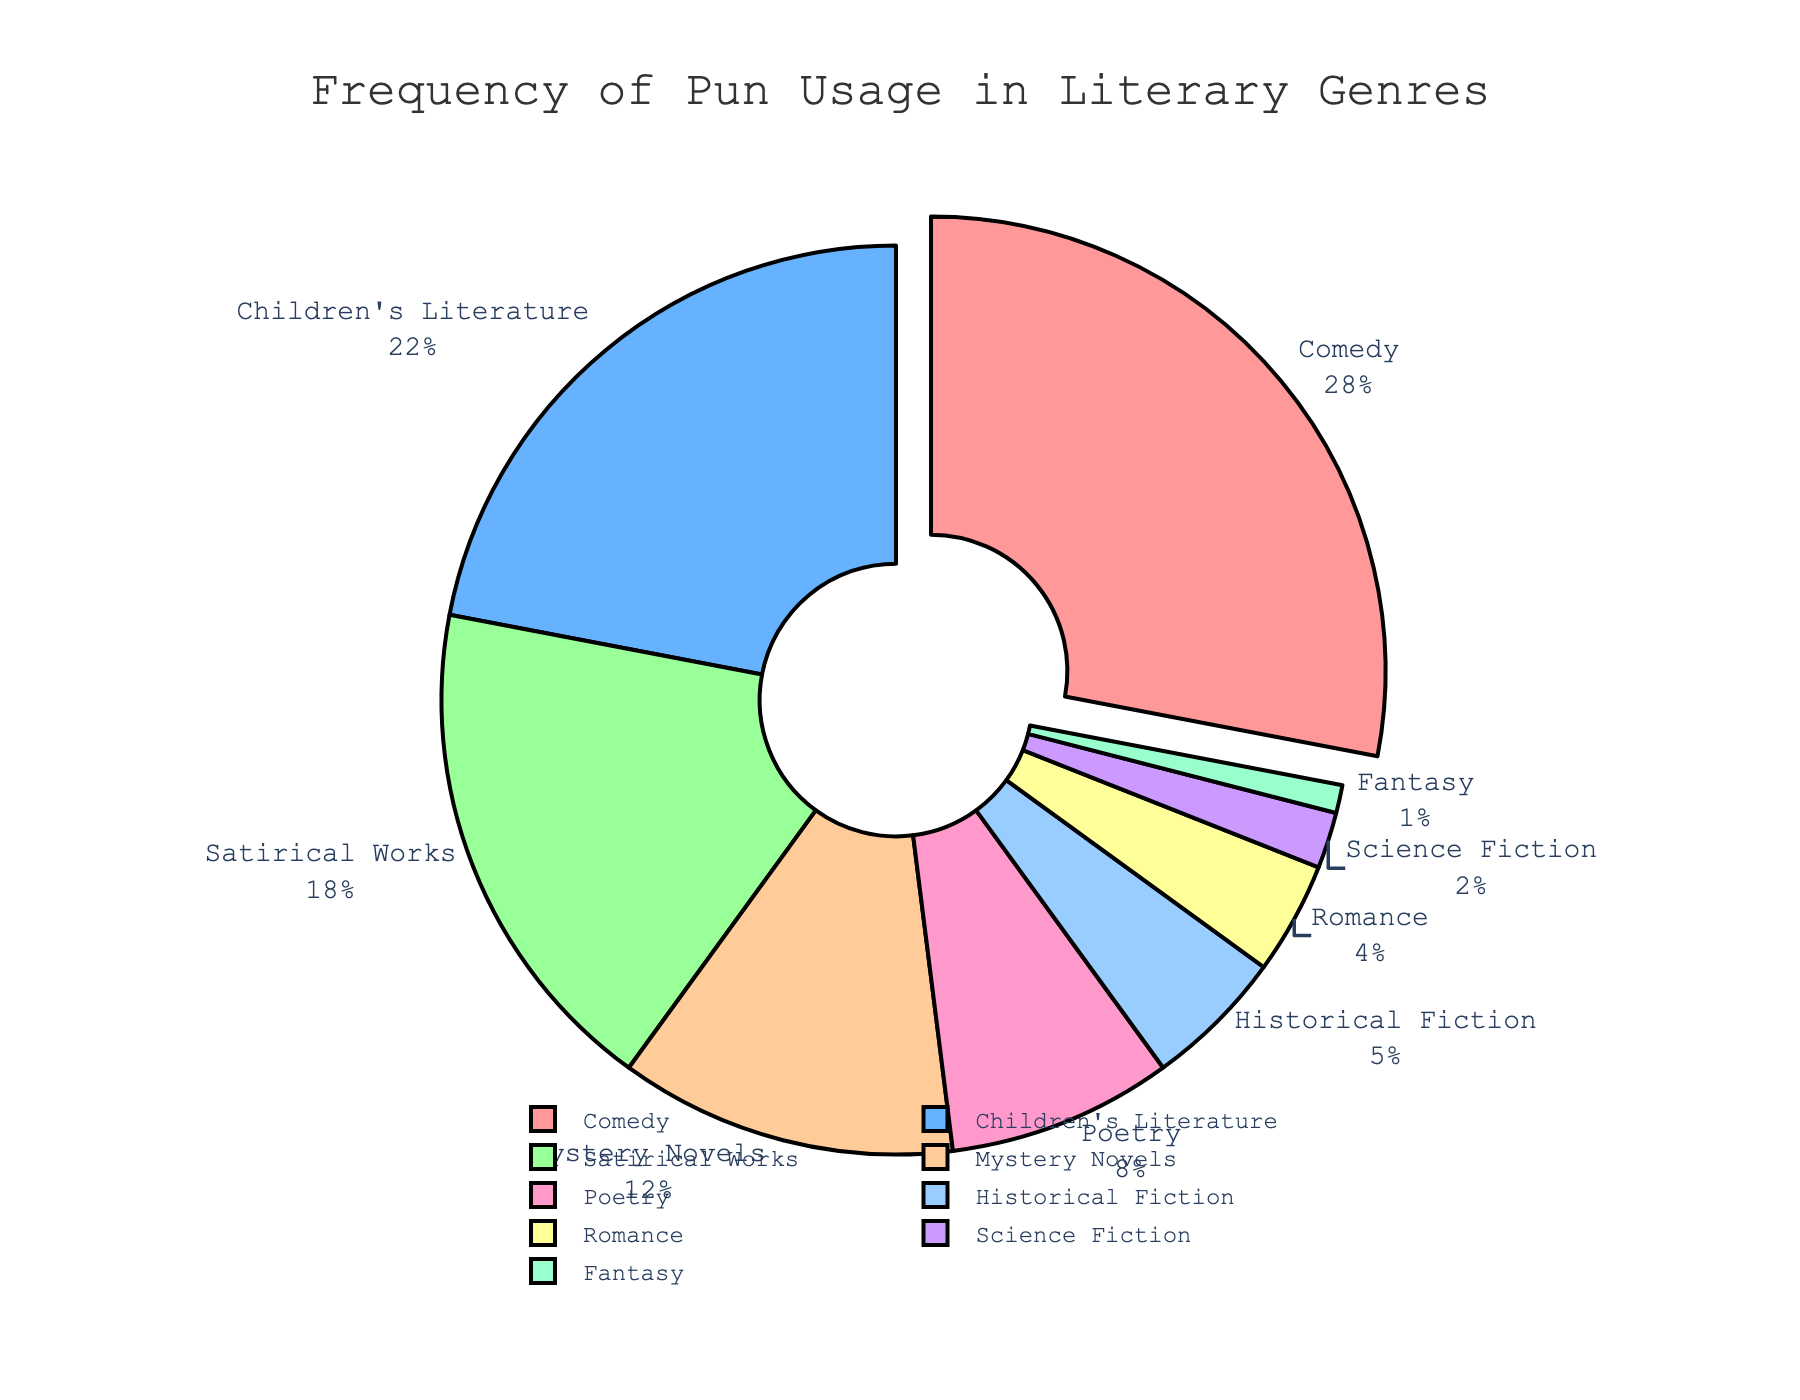What genre uses puns the most frequently? The slice pulled out from the pie chart indicates the genre with the highest percentage of pun usage. In this case, it is Comedy with 28%.
Answer: Comedy What is the combined percentage of pun usage in Historical Fiction and Science Fiction? From the pie chart, Historical Fiction accounts for 5%, and Science Fiction accounts for 2%. Adding these together, 5% + 2% = 7%.
Answer: 7% Which genres have a lower frequency of pun usage than Poetry? Poetry has a pun usage percentage of 8%. The genres with lower percentages are Historical Fiction (5%), Romance (4%), Science Fiction (2%), and Fantasy (1%).
Answer: Historical Fiction, Romance, Science Fiction, Fantasy How much more frequently are puns used in Satirical Works compared to Romance? From the chart, Satirical Works have a pun usage of 18%, while Romance has 4%. The difference is 18% - 4% = 14%.
Answer: 14% What's the total percentage of pun usage for genres under 10%? The genres under 10% are Poetry (8%), Historical Fiction (5%), Romance (4%), Science Fiction (2%), and Fantasy (1%). Summing these, 8% + 5% + 4% + 2% + 1% = 20%.
Answer: 20% Considering Comedy and Satirical Works together, what is their combined share of pun usage? Comedy has 28% and Satirical Works have 18%. Adding these together, 28% + 18% = 46%.
Answer: 46% Which genre's slice is colored using the third color in the sequence? The third color in the sequence belongs to Children's Literature, which has a percentage of 22%.
Answer: Children's Literature Is the usage of puns in Mystery Novels greater than, less than, or equal to the combined usage in Fantasy and Romance? Mystery Novels have a pun usage of 12%. Fantasy (1%) and Romance (4%) combined is 1% + 4% = 5%. Therefore, 12% is greater than 5%.
Answer: Greater than What is the average percentage of pun usage across all genres? Summing the percentages: 28% (Comedy) + 22% (Children's Literature) + 18% (Satirical Works) + 12% (Mystery Novels) + 8% (Poetry) + 5% (Historical Fiction) + 4% (Romance) + 2% (Science Fiction) + 1% (Fantasy) = 100%. There are 9 genres, so the average is 100% / 9 ≈ 11.11%.
Answer: 11.11% 